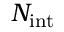<formula> <loc_0><loc_0><loc_500><loc_500>N _ { i n t }</formula> 